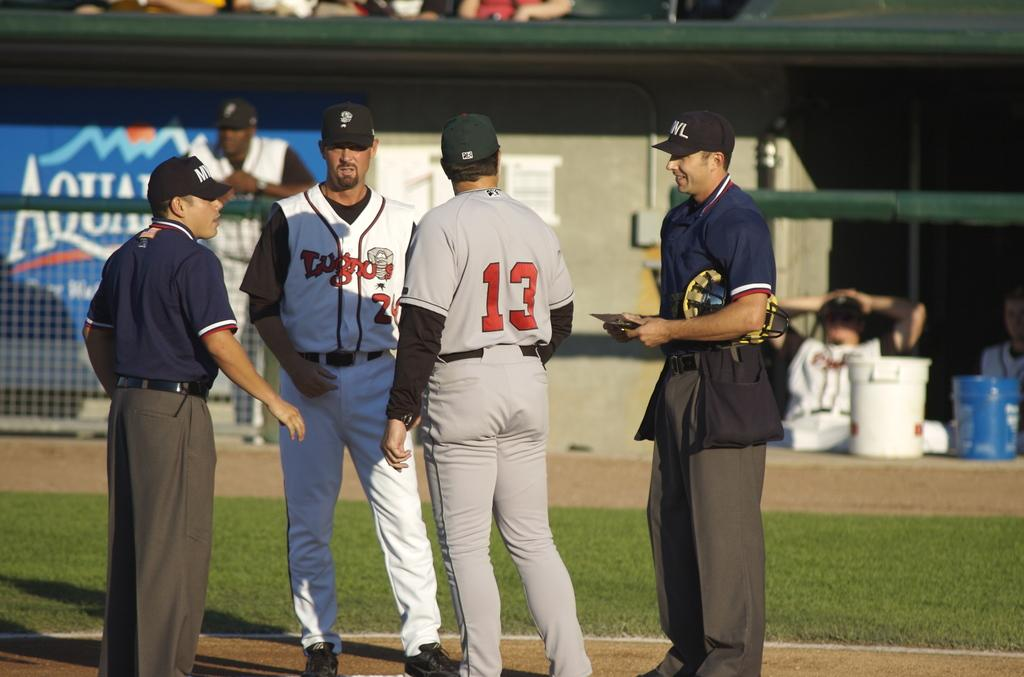<image>
Write a terse but informative summary of the picture. Player number 13 is walking over to confer with the referees. 